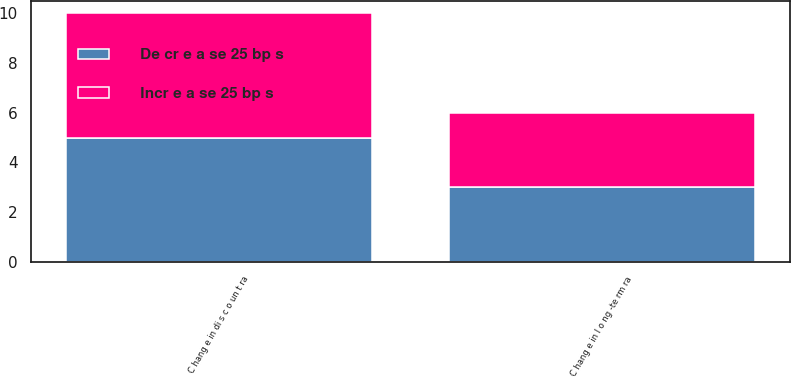<chart> <loc_0><loc_0><loc_500><loc_500><stacked_bar_chart><ecel><fcel>C hang e in di s c o un t ra<fcel>C hang e in l o ng -te rm ra<nl><fcel>De cr e a se 25 bp s<fcel>5<fcel>3<nl><fcel>Incr e a se 25 bp s<fcel>5<fcel>3<nl></chart> 